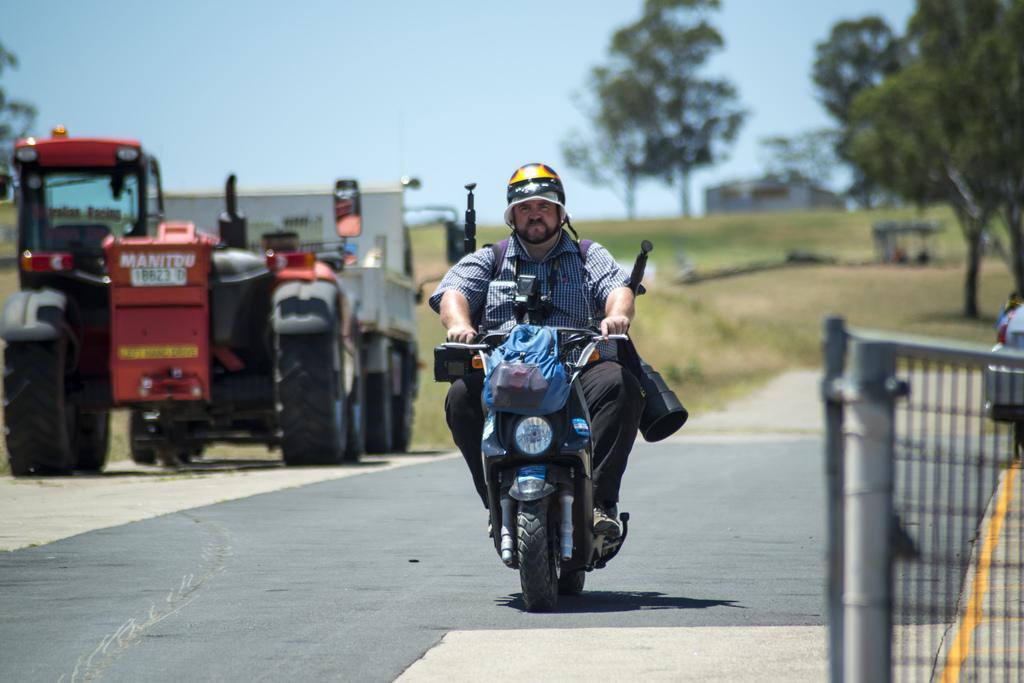How would you summarize this image in a sentence or two? In this picture I can see there is a person riding the motor cycle and he is wearing a helmet, there are few carry bags attached to the motor cycle and there is a truck and trees in the backdrop and the sky is clear. The backdrop is blurred. 